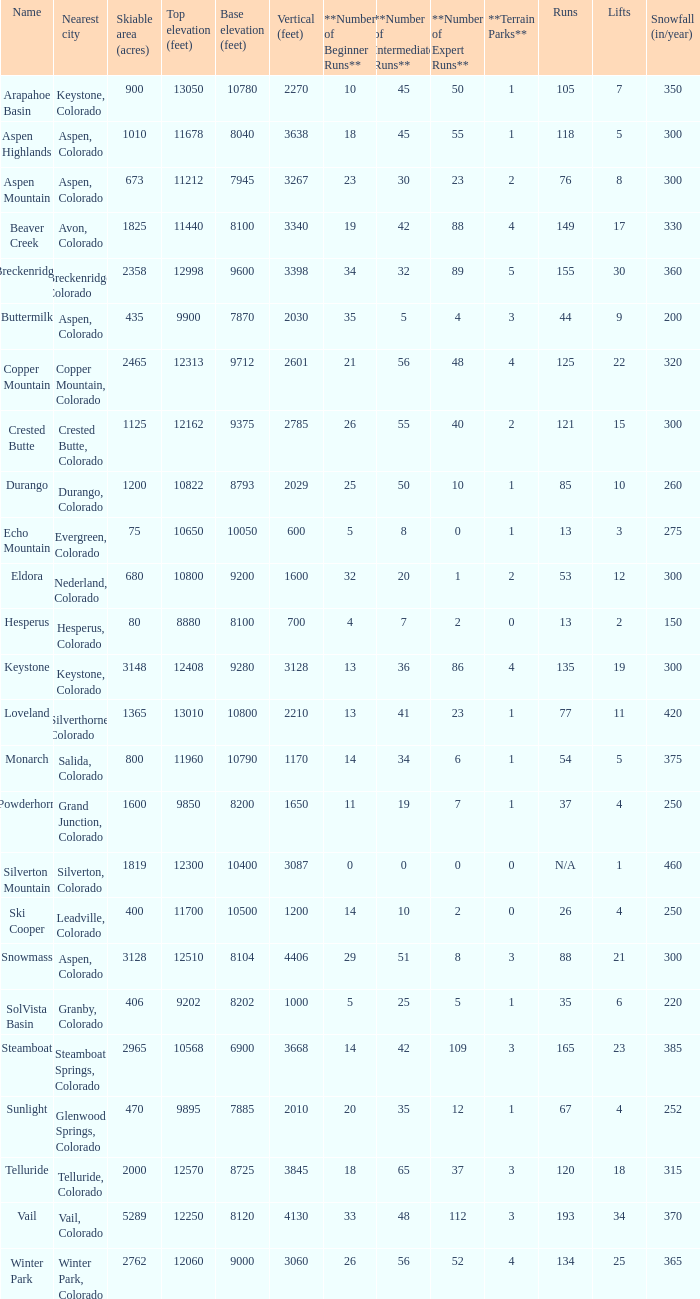What is the snowfall for ski resort Snowmass? 300.0. 